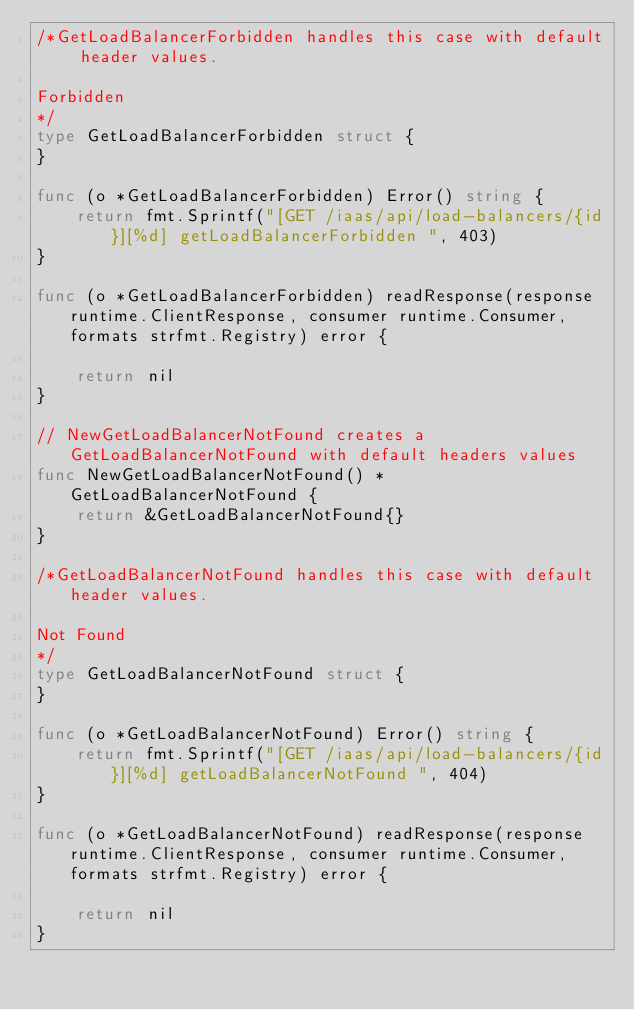<code> <loc_0><loc_0><loc_500><loc_500><_Go_>/*GetLoadBalancerForbidden handles this case with default header values.

Forbidden
*/
type GetLoadBalancerForbidden struct {
}

func (o *GetLoadBalancerForbidden) Error() string {
	return fmt.Sprintf("[GET /iaas/api/load-balancers/{id}][%d] getLoadBalancerForbidden ", 403)
}

func (o *GetLoadBalancerForbidden) readResponse(response runtime.ClientResponse, consumer runtime.Consumer, formats strfmt.Registry) error {

	return nil
}

// NewGetLoadBalancerNotFound creates a GetLoadBalancerNotFound with default headers values
func NewGetLoadBalancerNotFound() *GetLoadBalancerNotFound {
	return &GetLoadBalancerNotFound{}
}

/*GetLoadBalancerNotFound handles this case with default header values.

Not Found
*/
type GetLoadBalancerNotFound struct {
}

func (o *GetLoadBalancerNotFound) Error() string {
	return fmt.Sprintf("[GET /iaas/api/load-balancers/{id}][%d] getLoadBalancerNotFound ", 404)
}

func (o *GetLoadBalancerNotFound) readResponse(response runtime.ClientResponse, consumer runtime.Consumer, formats strfmt.Registry) error {

	return nil
}
</code> 